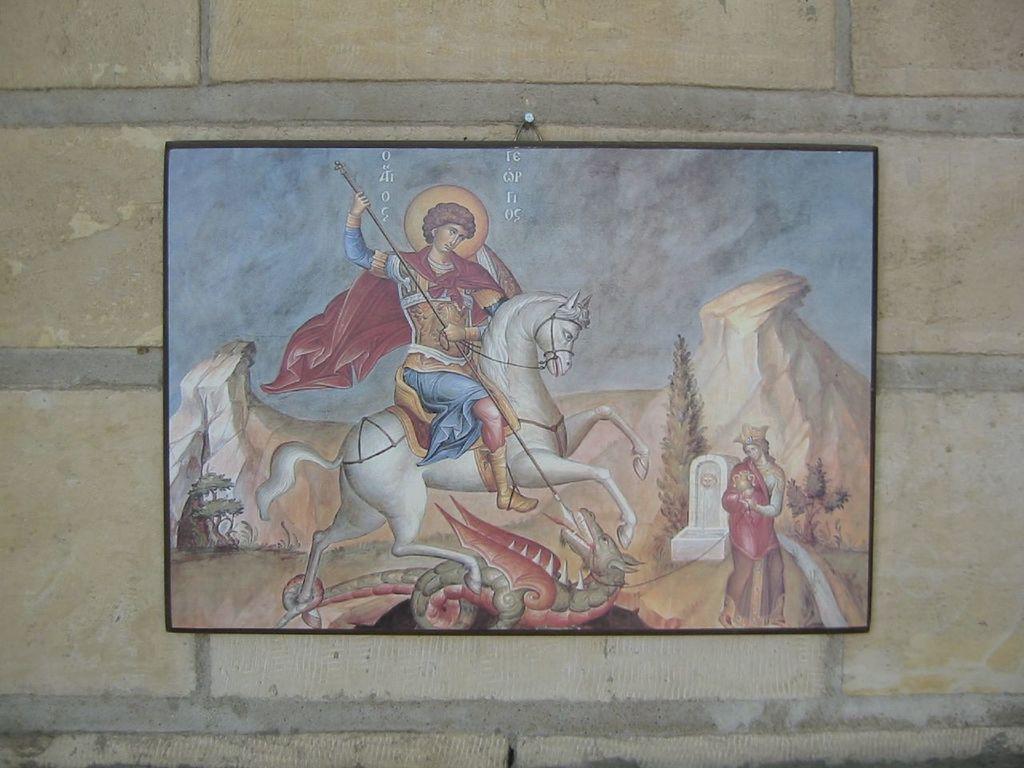Can you describe this image briefly? In this image, we can see a painting of a frame which is attached to a wall. In the painting, we can see a man riding on the horse. On the right side of the painting, we can also see another person, rocks, trees. At the bottom of the painting, we can also see an animal. In the background of the painting, we can see blue color. 